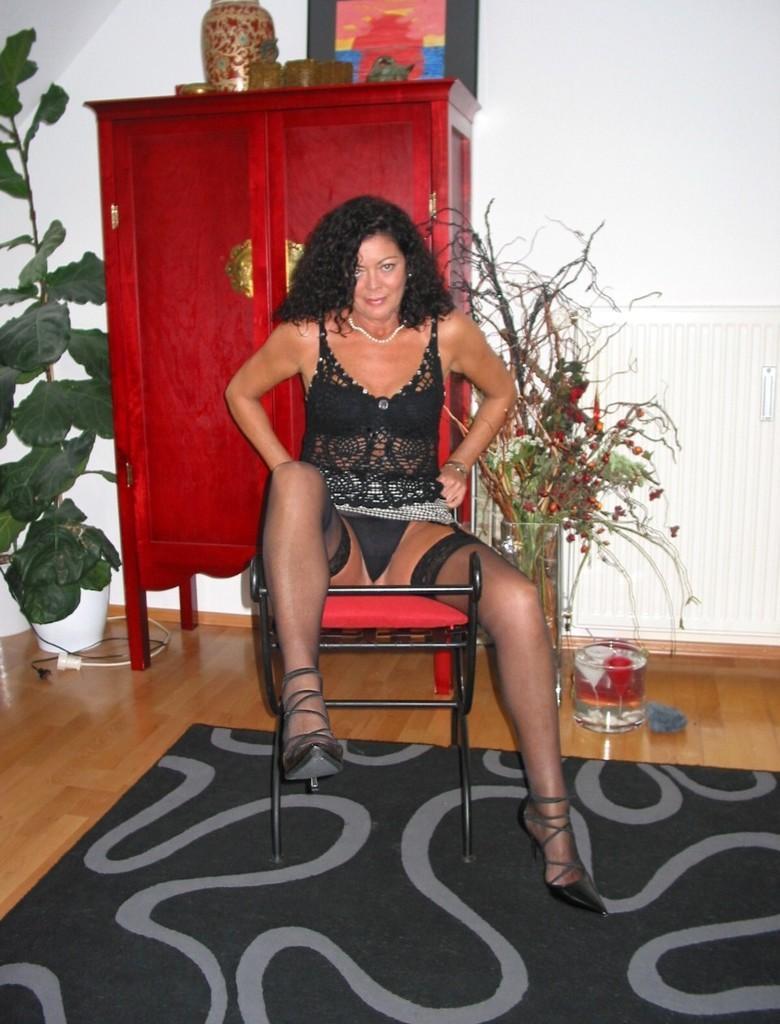In one or two sentences, can you explain what this image depicts? In this picture we can see a woman sitting on a chair. Here we can see objects on the floor. This is a floor carpet. In the background we can see a frame, vase and other objects on a cupboard. This is a house plant with a pot. In the background we can see a wall painted with white paint. 